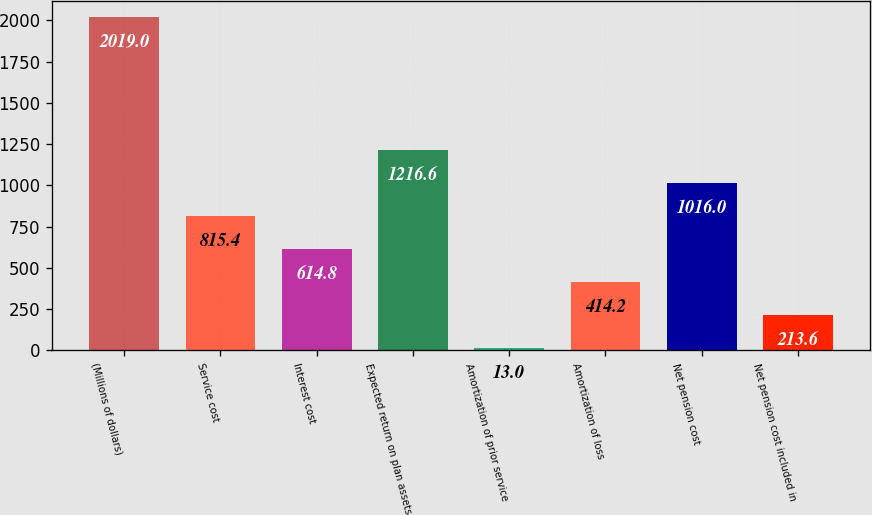<chart> <loc_0><loc_0><loc_500><loc_500><bar_chart><fcel>(Millions of dollars)<fcel>Service cost<fcel>Interest cost<fcel>Expected return on plan assets<fcel>Amortization of prior service<fcel>Amortization of loss<fcel>Net pension cost<fcel>Net pension cost included in<nl><fcel>2019<fcel>815.4<fcel>614.8<fcel>1216.6<fcel>13<fcel>414.2<fcel>1016<fcel>213.6<nl></chart> 